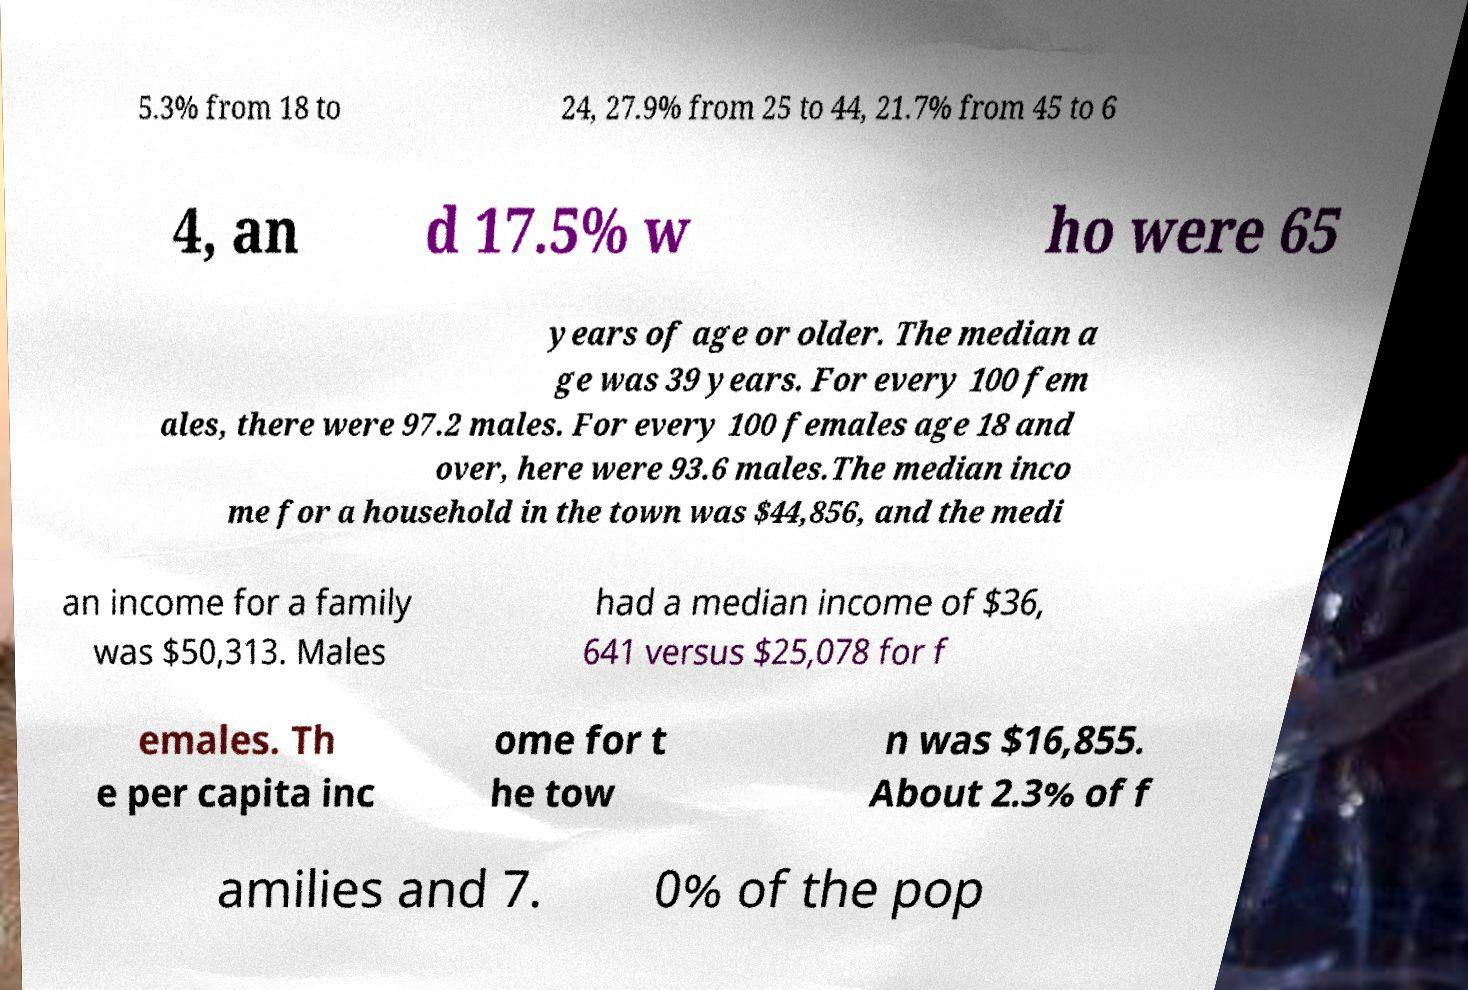Please identify and transcribe the text found in this image. 5.3% from 18 to 24, 27.9% from 25 to 44, 21.7% from 45 to 6 4, an d 17.5% w ho were 65 years of age or older. The median a ge was 39 years. For every 100 fem ales, there were 97.2 males. For every 100 females age 18 and over, here were 93.6 males.The median inco me for a household in the town was $44,856, and the medi an income for a family was $50,313. Males had a median income of $36, 641 versus $25,078 for f emales. Th e per capita inc ome for t he tow n was $16,855. About 2.3% of f amilies and 7. 0% of the pop 